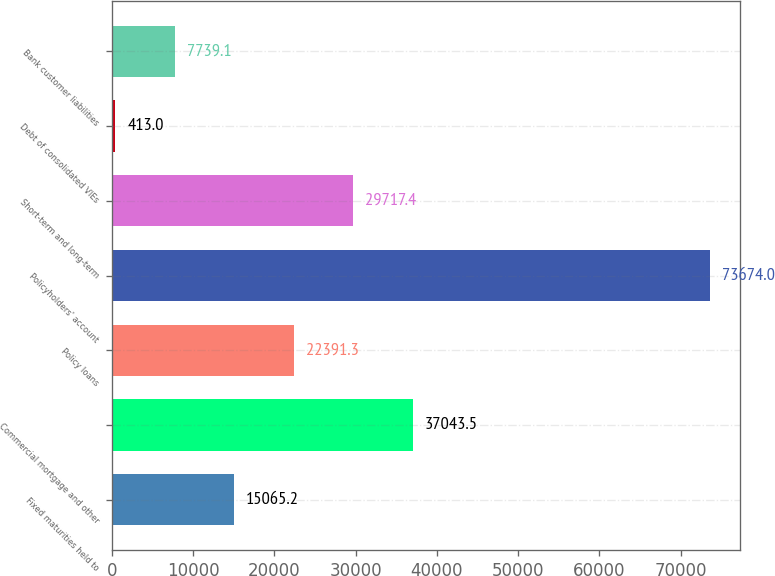Convert chart to OTSL. <chart><loc_0><loc_0><loc_500><loc_500><bar_chart><fcel>Fixed maturities held to<fcel>Commercial mortgage and other<fcel>Policy loans<fcel>Policyholders' account<fcel>Short-term and long-term<fcel>Debt of consolidated VIEs<fcel>Bank customer liabilities<nl><fcel>15065.2<fcel>37043.5<fcel>22391.3<fcel>73674<fcel>29717.4<fcel>413<fcel>7739.1<nl></chart> 